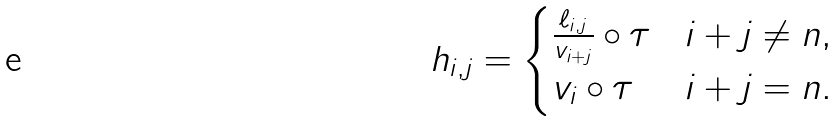Convert formula to latex. <formula><loc_0><loc_0><loc_500><loc_500>h _ { i , j } = \begin{cases} \frac { \ell _ { i , j } } { v _ { i + j } } \circ \tau & \text {$i+j \neq n $} , \\ v _ { i } \circ \tau & i + j = n . \end{cases}</formula> 